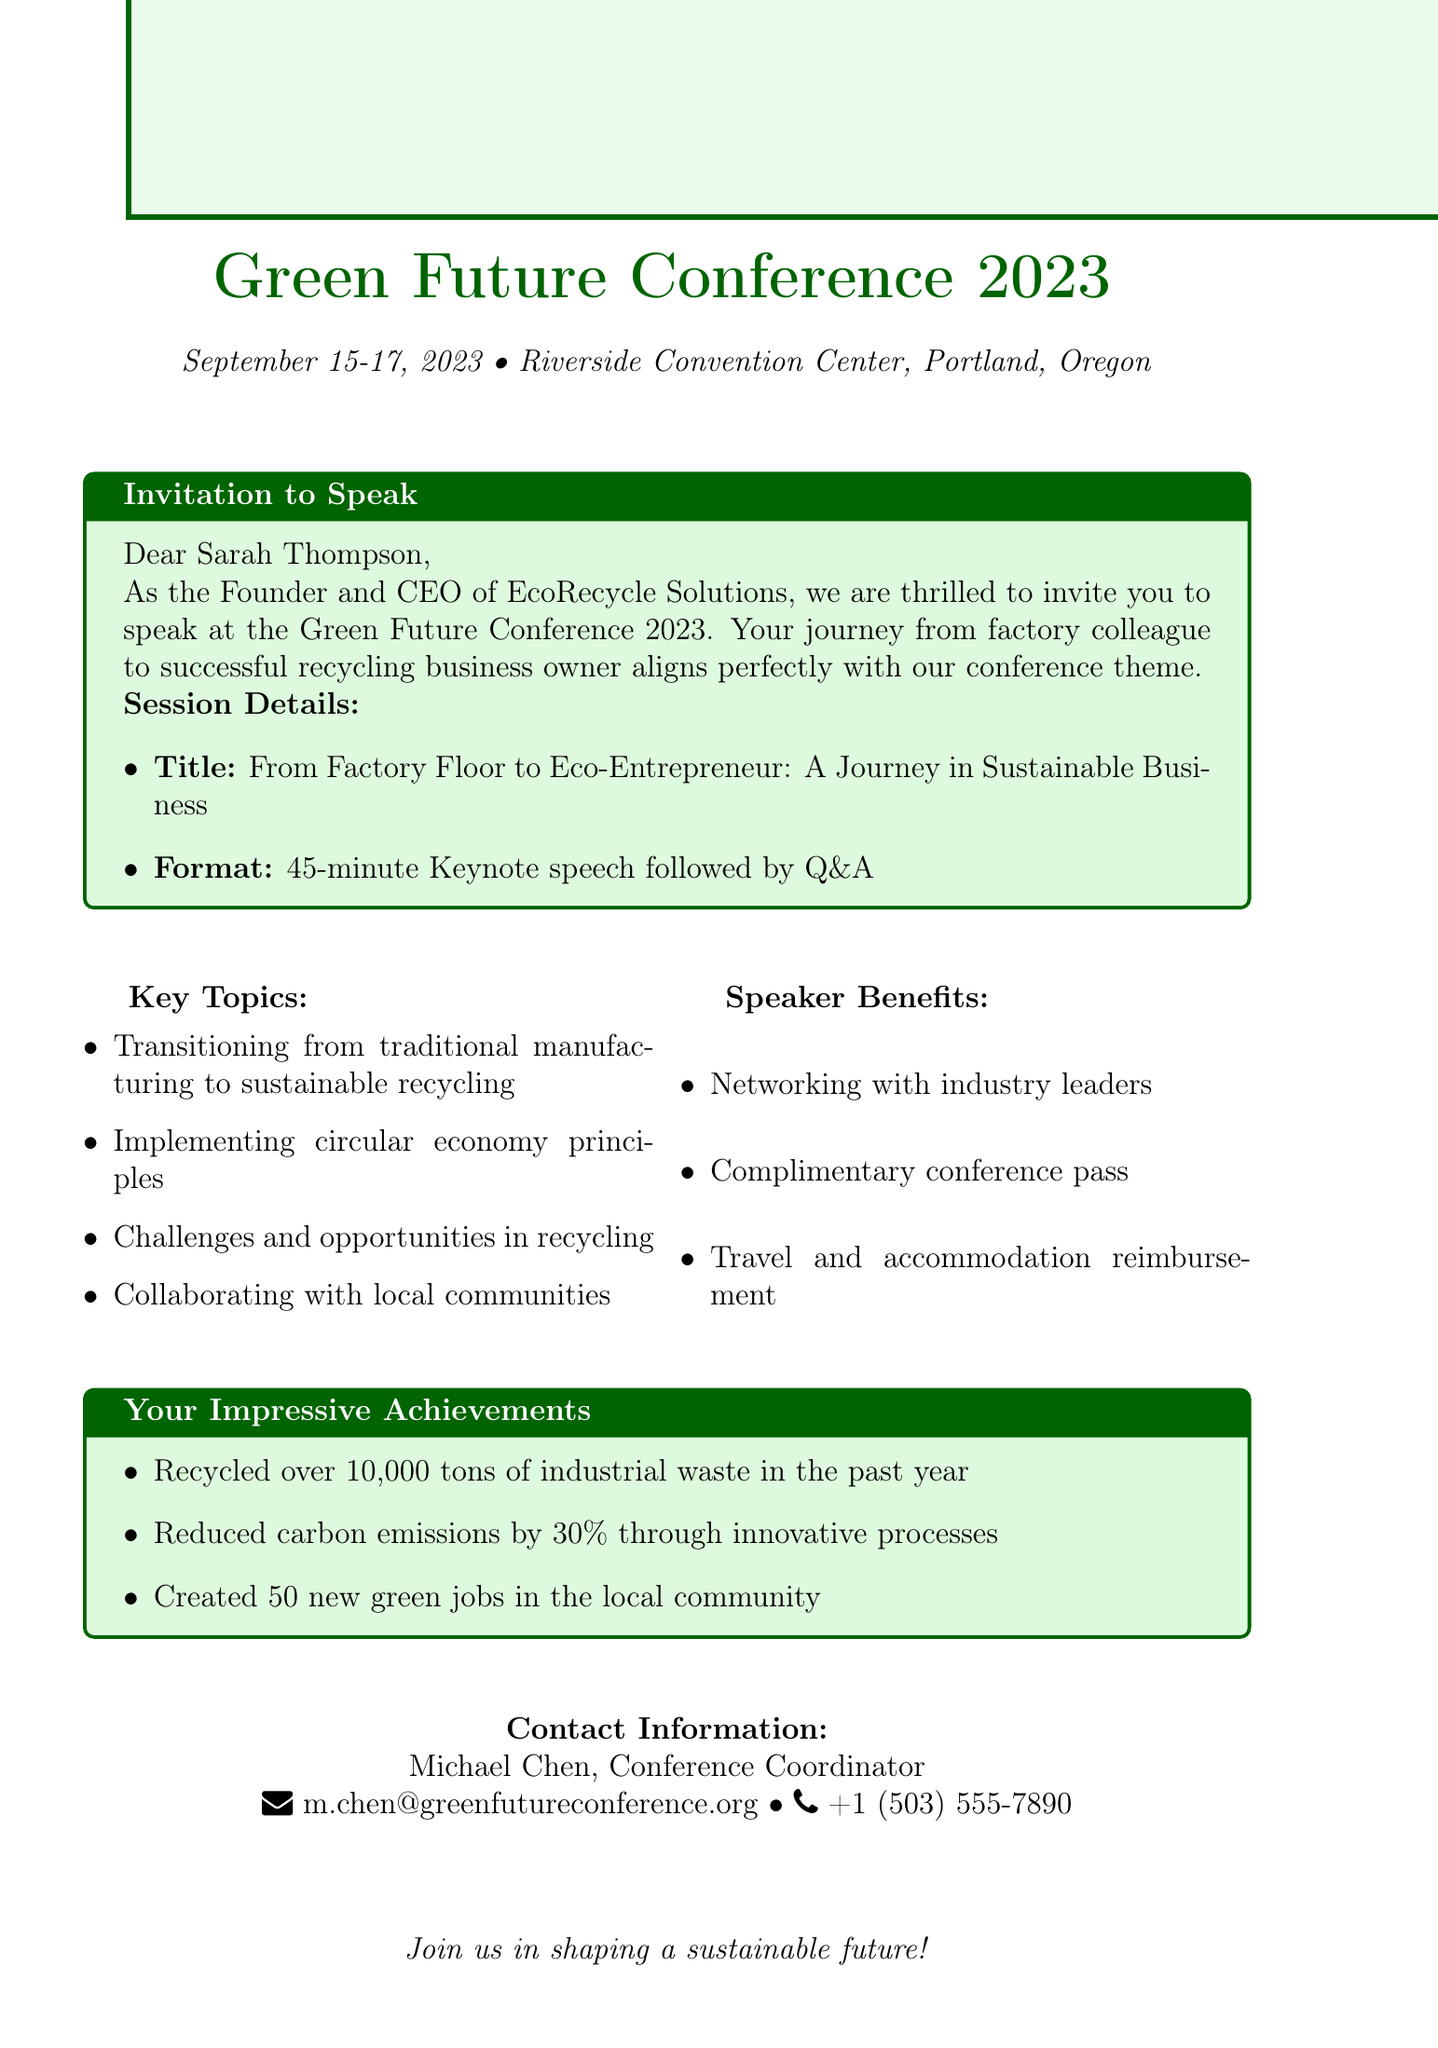What is the name of the conference? The name of the conference is explicitly mentioned as part of the conference details in the document.
Answer: Green Future Conference 2023 Who is the sender of the invitation? The document lists the sender's information at the beginning, which includes their name and company.
Answer: Sarah Thompson What are the dates of the conference? The dates provided in the document are clearly stated as part of the conference details.
Answer: September 15-17, 2023 What is the session duration for the keynote speech? The session duration is specified in the invitation details section of the document.
Answer: 45 minutes What is one key topic of the session? One of the key topics is mentioned in the key topics section of the document, and multiple options are available.
Answer: Transitioning from traditional manufacturing to sustainable recycling What benefit does a speaker receive regarding travel? The speaker benefits section outlines the advantages speakers gain, including travel-related details.
Answer: Travel and accommodation reimbursement Who is the contact person for the conference? The document lists the contact information for the conference coordinator, including their name and position.
Answer: Michael Chen What is one of the sustainability achievements mentioned? The document provides a list of sustainability achievements directly associated with the founder's business.
Answer: Recycled over 10,000 tons of industrial waste in the past year What is the format of the session? The invitation details specify the format of the session, providing clear information on how it will be structured.
Answer: Keynote speech followed by Q&A 